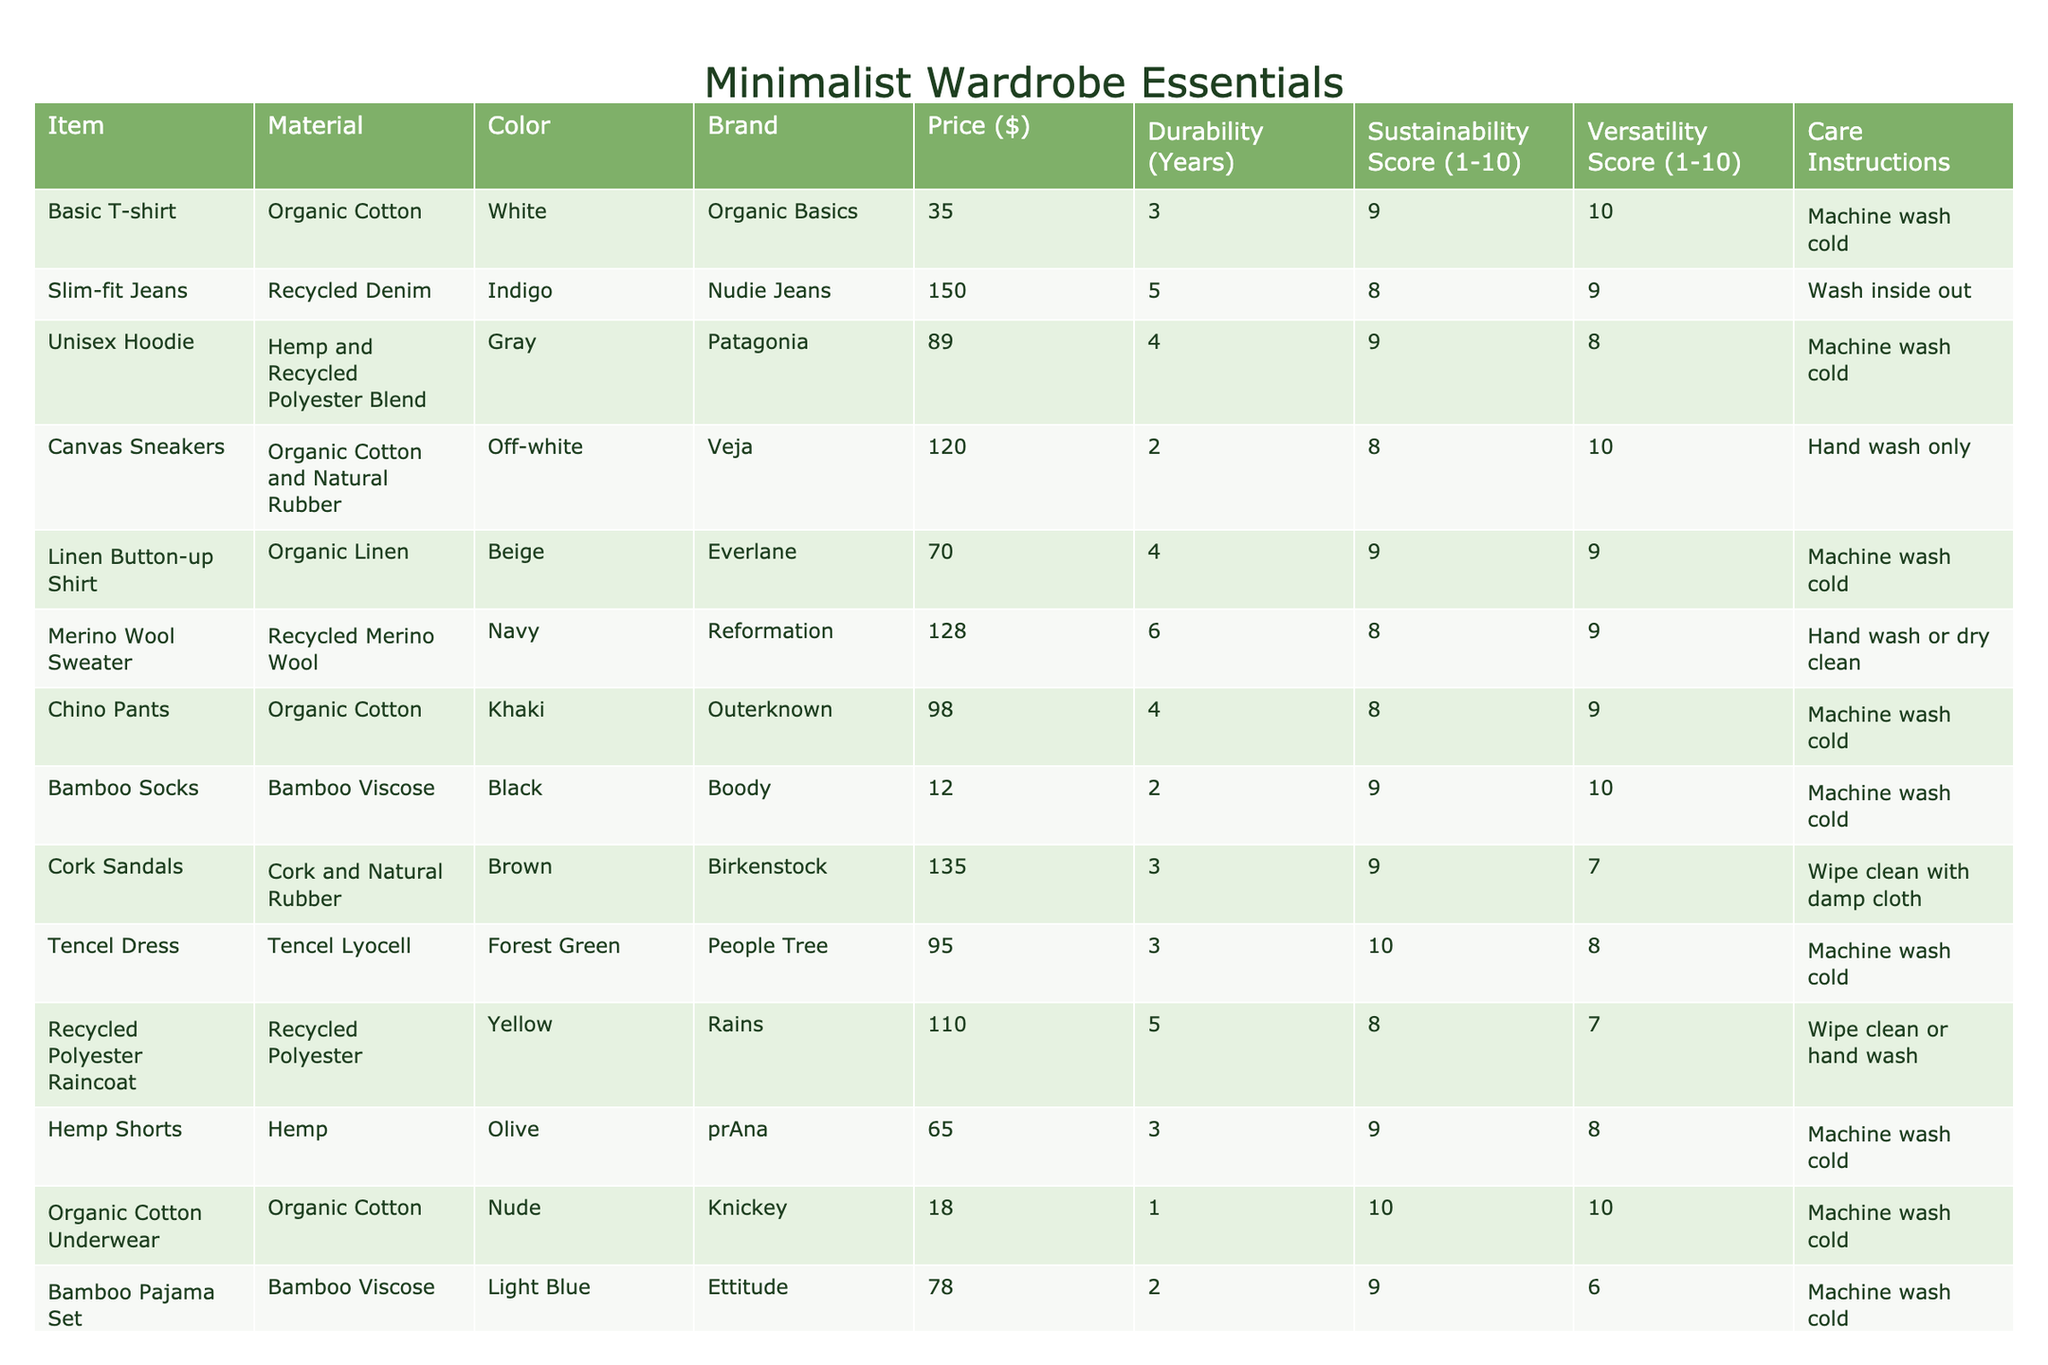What is the price of the Organic Cotton Underwear? The table lists the Organic Cotton Underwear's price under the "Price ($)" column, which shows it is $18.
Answer: $18 How many years is the durability of the Merino Wool Sweater? The "Durability (Years)" column for the Merino Wool Sweater indicates it lasts 6 years.
Answer: 6 years Which item has the highest sustainability score? By comparing the "Sustainability Score (1-10)" column, the Tencel Dress has a score of 10, which is the highest.
Answer: Tencel Dress What color is the Canvas Sneakers? The "Color" column for the Canvas Sneakers indicates that they are off-white.
Answer: Off-white What is the average price of all the items listed? To find the average price, we add all the prices: (35 + 150 + 89 + 120 + 70 + 128 + 98 + 12 + 135 + 95 + 110 + 65 + 18 + 78 + 32) = 1122, then divide by the number of items (15), which gives us an average of 1122/15 = 74.8.
Answer: $74.8 How many items have a versatility score of 10? By checking the "Versatility Score (1-10)" column, we find that both the Basic T-shirt and Organic Cotton Underwear have a score of 10, thus counting them results in 2 items.
Answer: 2 items Which brand has the cheapest item? Scanning through the "Price ($)" column, the item with the lowest price is the Bamboo Socks at $12, which is from the brand Boody.
Answer: Boody Is the Chino Pants made from synthetic materials? The "Material" column shows the Chino Pants are made from organic cotton, which is a natural material, not synthetic.
Answer: No What is the total durability score of all items combined? We sum the durability scores: (3 + 5 + 4 + 2 + 4 + 6 + 4 + 2 + 3 + 3 + 5 + 3 + 1 + 2 + 4) = 58.
Answer: 58 Which item requires hand washing only? Examining the "Care Instructions," the Canvas Sneakers specify that they require hand wash only.
Answer: Canvas Sneakers How many items have a sustainability score of 9? The table shows that 6 items (Basic T-shirt, Unisex Hoodie, Bamboo Socks, Hemp Shorts, Linen Tote Bag, and Cork Sandals) have a sustainability score of 9.
Answer: 6 items 